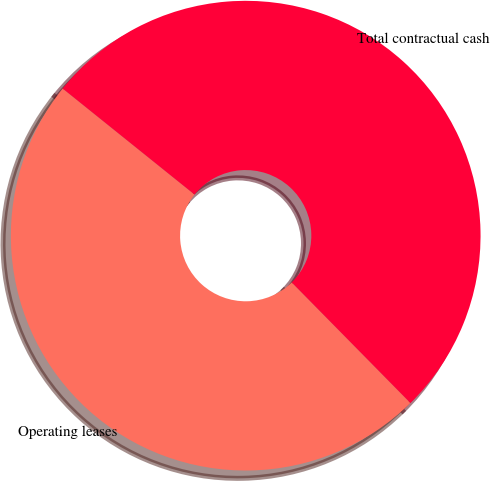Convert chart. <chart><loc_0><loc_0><loc_500><loc_500><pie_chart><fcel>Operating leases<fcel>Total contractual cash<nl><fcel>48.15%<fcel>51.85%<nl></chart> 